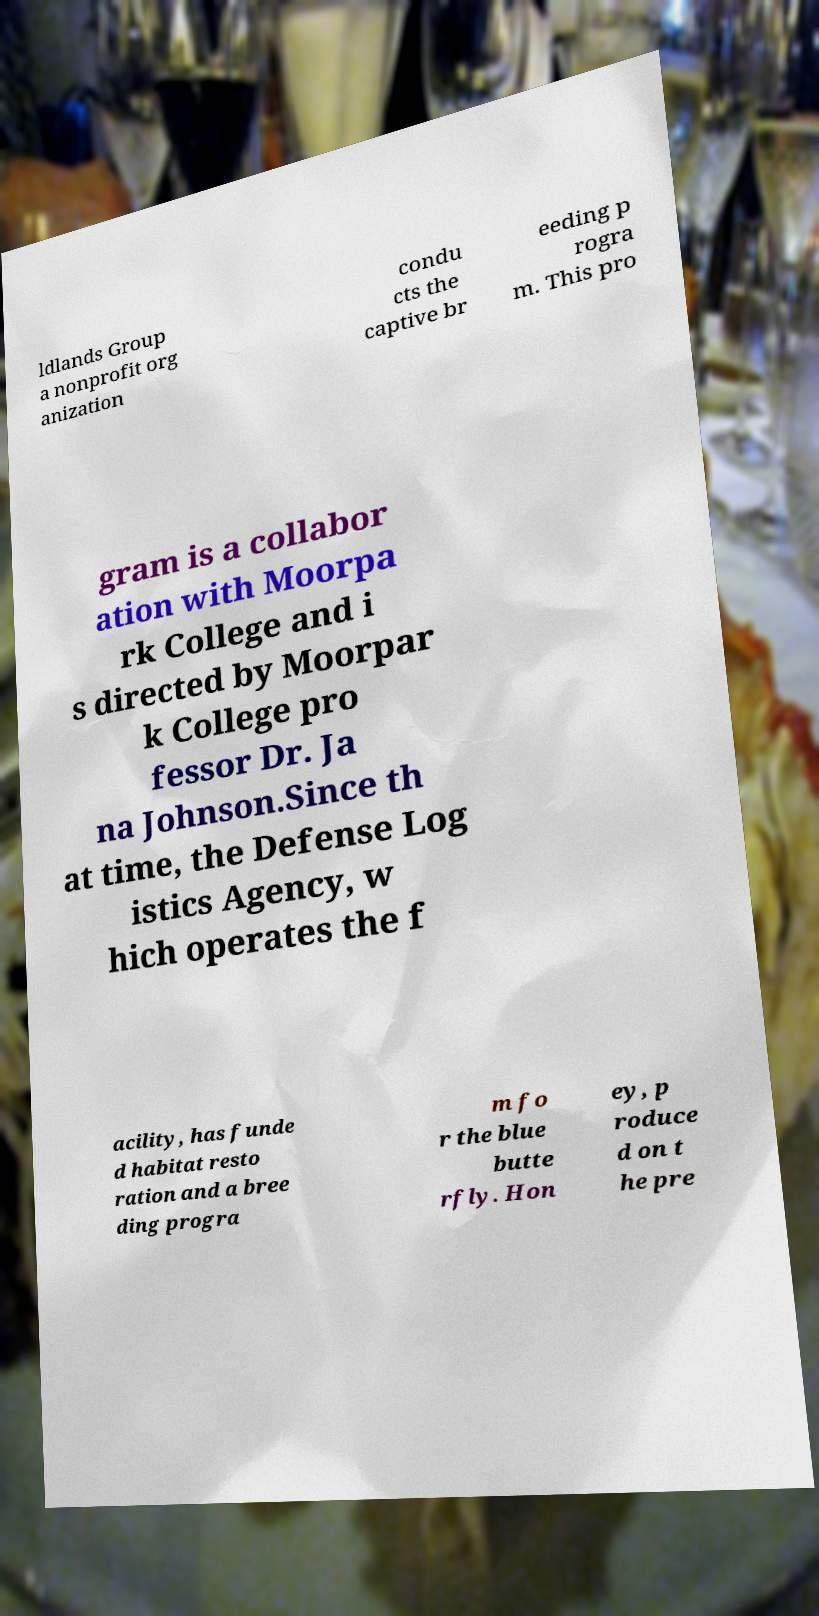Can you accurately transcribe the text from the provided image for me? ldlands Group a nonprofit org anization condu cts the captive br eeding p rogra m. This pro gram is a collabor ation with Moorpa rk College and i s directed by Moorpar k College pro fessor Dr. Ja na Johnson.Since th at time, the Defense Log istics Agency, w hich operates the f acility, has funde d habitat resto ration and a bree ding progra m fo r the blue butte rfly. Hon ey, p roduce d on t he pre 